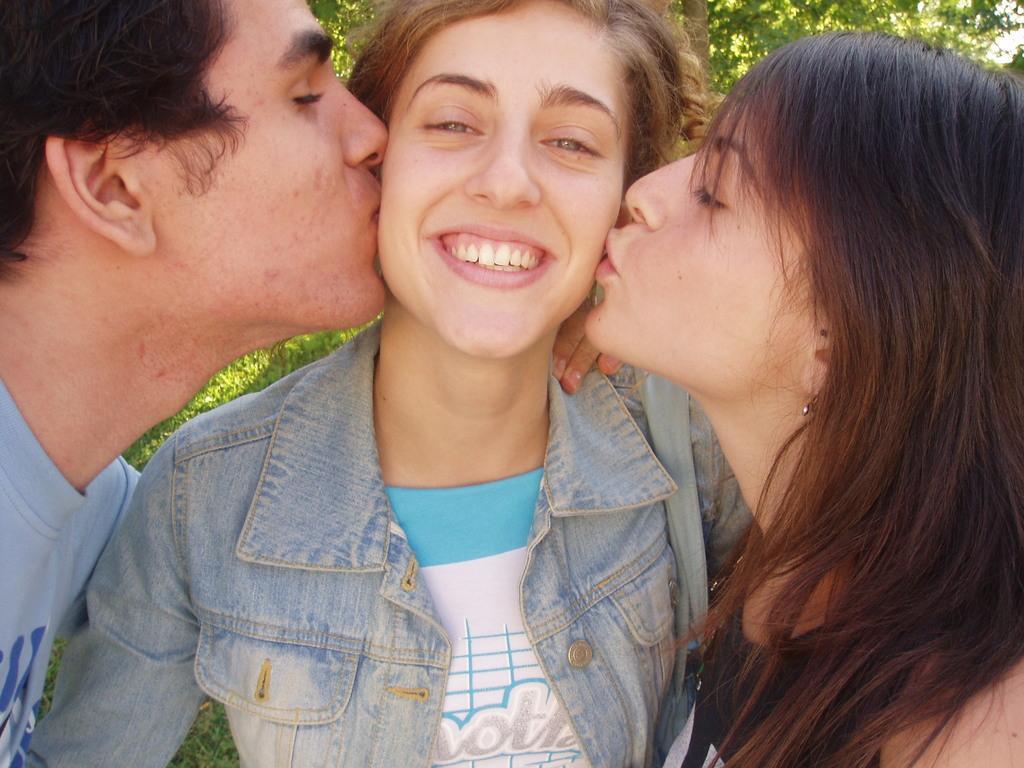Describe this image in one or two sentences. In this image there are persons standing in the front. In the center the woman is standing and smiling. In the background there are trees. 